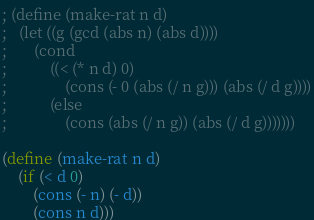<code> <loc_0><loc_0><loc_500><loc_500><_Scheme_>; (define (make-rat n d)
; 	(let ((g (gcd (abs n) (abs d))))
; 		(cond 
; 			((< (* n d) 0) 
; 				(cons (- 0 (abs (/ n g))) (abs (/ d g))))
; 			(else 
; 				(cons (abs (/ n g)) (abs (/ d g)))))))

(define (make-rat n d)
    (if (< d 0)
        (cons (- n) (- d))
        (cons n d)))</code> 